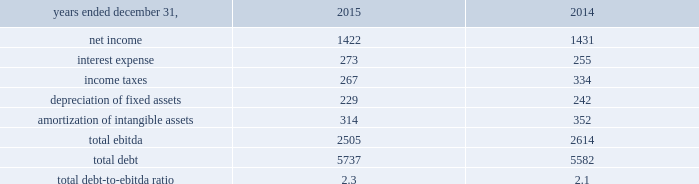On may 20 , 2015 , aon plc issued $ 600 million of 4.750% ( 4.750 % ) senior notes due may 2045 .
The 4.750% ( 4.750 % ) notes due may 2045 are fully and unconditionally guaranteed by aon corporation .
We used the proceeds of the issuance for general corporate purposes .
On september 30 , 2015 , $ 600 million of 3.50% ( 3.50 % ) senior notes issued by aon corporation matured and were repaid .
On november 13 , 2015 , aon plc issued $ 400 million of 2.80% ( 2.80 % ) senior notes due march 2021 .
The 2.80% ( 2.80 % ) notes due march 2021 are fully and unconditionally guaranteed by aon corporation .
We used the proceeds of the issuance for general corporate purposes .
Credit facilities as of december 31 , 2015 , we had two committed credit facilities outstanding : our $ 400 million u.s .
Credit facility expiring in march 2017 ( the "2017 facility" ) and $ 900 million multi-currency u.s .
Credit facility expiring in february 2020 ( the "2020 facility" ) .
The 2020 facility was entered into on february 2 , 2015 and replaced the previous 20ac650 million european credit facility .
Each of these facilities is intended to support our commercial paper obligations and our general working capital needs .
In addition , each of these facilities includes customary representations , warranties and covenants , including financial covenants that require us to maintain specified ratios of adjusted consolidated ebitda to consolidated interest expense and consolidated debt to adjusted consolidated ebitda , tested quarterly .
At december 31 , 2015 , we did not have borrowings under either the 2017 facility or the 2020 facility , and we were in compliance with the financial covenants and all other covenants contained therein during the twelve months ended december 31 , 2015 .
Effective february 2 , 2016 , the 2020 facility terms were extended for 1 year and will expire in february 2021 our total debt-to-ebitda ratio at december 31 , 2015 and 2014 , is calculated as follows: .
We use ebitda , as defined by our financial covenants , as a non-gaap measure .
This supplemental information related to ebitda represents a measure not in accordance with u.s .
Gaap and should be viewed in addition to , not instead of , our consolidated financial statements and notes thereto .
Shelf registration statement on september 3 , 2015 , we filed a shelf registration statement with the sec , registering the offer and sale from time to time of an indeterminate amount of , among other securities , debt securities , preference shares , class a ordinary shares and convertible securities .
Our ability to access the market as a source of liquidity is dependent on investor demand , market conditions and other factors. .
What is the time-interest-earned ratio for 2015? 
Computations: (2505 / 273)
Answer: 9.17582. On may 20 , 2015 , aon plc issued $ 600 million of 4.750% ( 4.750 % ) senior notes due may 2045 .
The 4.750% ( 4.750 % ) notes due may 2045 are fully and unconditionally guaranteed by aon corporation .
We used the proceeds of the issuance for general corporate purposes .
On september 30 , 2015 , $ 600 million of 3.50% ( 3.50 % ) senior notes issued by aon corporation matured and were repaid .
On november 13 , 2015 , aon plc issued $ 400 million of 2.80% ( 2.80 % ) senior notes due march 2021 .
The 2.80% ( 2.80 % ) notes due march 2021 are fully and unconditionally guaranteed by aon corporation .
We used the proceeds of the issuance for general corporate purposes .
Credit facilities as of december 31 , 2015 , we had two committed credit facilities outstanding : our $ 400 million u.s .
Credit facility expiring in march 2017 ( the "2017 facility" ) and $ 900 million multi-currency u.s .
Credit facility expiring in february 2020 ( the "2020 facility" ) .
The 2020 facility was entered into on february 2 , 2015 and replaced the previous 20ac650 million european credit facility .
Each of these facilities is intended to support our commercial paper obligations and our general working capital needs .
In addition , each of these facilities includes customary representations , warranties and covenants , including financial covenants that require us to maintain specified ratios of adjusted consolidated ebitda to consolidated interest expense and consolidated debt to adjusted consolidated ebitda , tested quarterly .
At december 31 , 2015 , we did not have borrowings under either the 2017 facility or the 2020 facility , and we were in compliance with the financial covenants and all other covenants contained therein during the twelve months ended december 31 , 2015 .
Effective february 2 , 2016 , the 2020 facility terms were extended for 1 year and will expire in february 2021 our total debt-to-ebitda ratio at december 31 , 2015 and 2014 , is calculated as follows: .
We use ebitda , as defined by our financial covenants , as a non-gaap measure .
This supplemental information related to ebitda represents a measure not in accordance with u.s .
Gaap and should be viewed in addition to , not instead of , our consolidated financial statements and notes thereto .
Shelf registration statement on september 3 , 2015 , we filed a shelf registration statement with the sec , registering the offer and sale from time to time of an indeterminate amount of , among other securities , debt securities , preference shares , class a ordinary shares and convertible securities .
Our ability to access the market as a source of liquidity is dependent on investor demand , market conditions and other factors. .
What is the ebit of aon for 2015? 
Computations: ((2505 - 314) - 229)
Answer: 1962.0. 